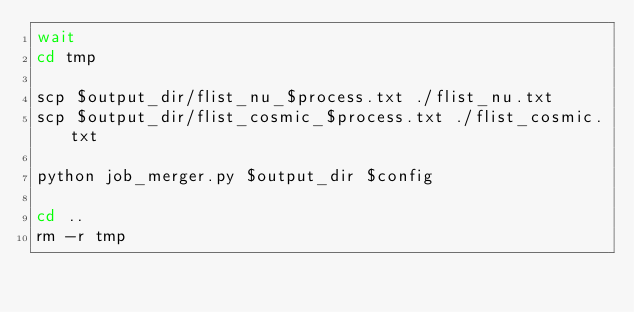<code> <loc_0><loc_0><loc_500><loc_500><_Bash_>wait
cd tmp

scp $output_dir/flist_nu_$process.txt ./flist_nu.txt
scp $output_dir/flist_cosmic_$process.txt ./flist_cosmic.txt

python job_merger.py $output_dir $config

cd ..
rm -r tmp


</code> 